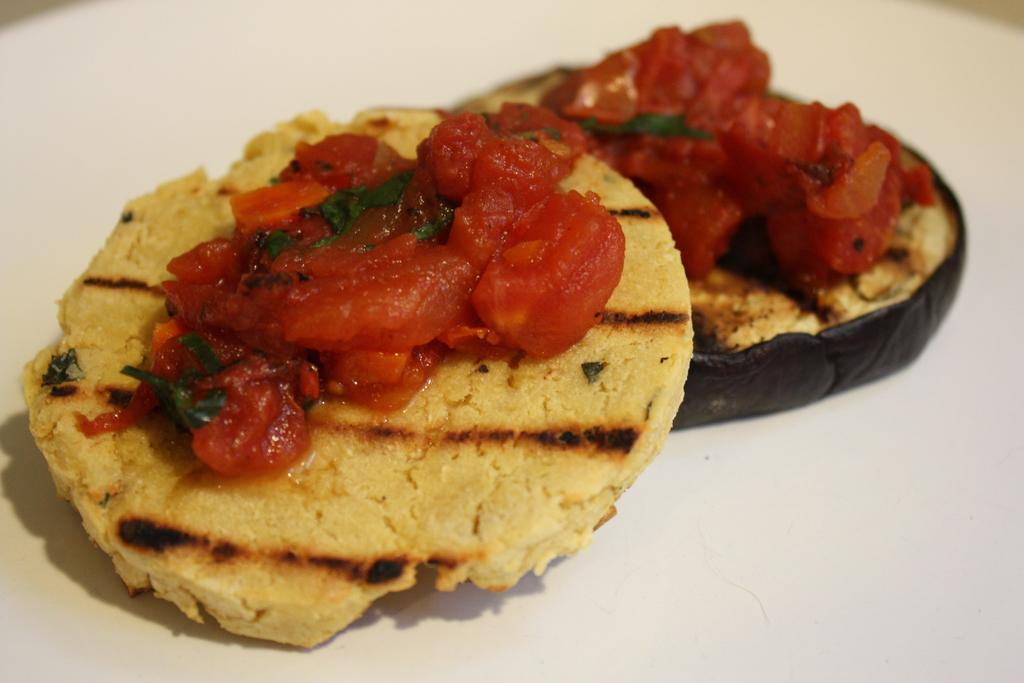What type of food items are present in the image? The food items in the image resemble biscuits. What is the color of the surface on which the food items are placed? The food items are on a white surface. What type of rule is being enforced in the image? There is no rule being enforced in the image; it features food items resembling biscuits on a white surface. Can you tell me how many tickets are visible in the image? There are no tickets present in the image. 